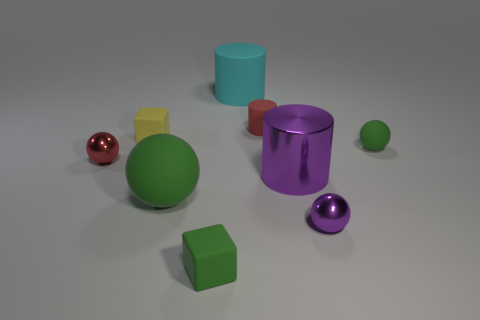Are there any patterns or symmetry in the arrangement of objects? The arrangement of objects in the image does not display a deliberate pattern or symmetry. The objects are scattered in a seemingly random fashion, with varying distances between them, and no apparent order in terms of color, size, or shape. This lack of pattern or symmetry gives the composition a casual, unstructured appearance. 